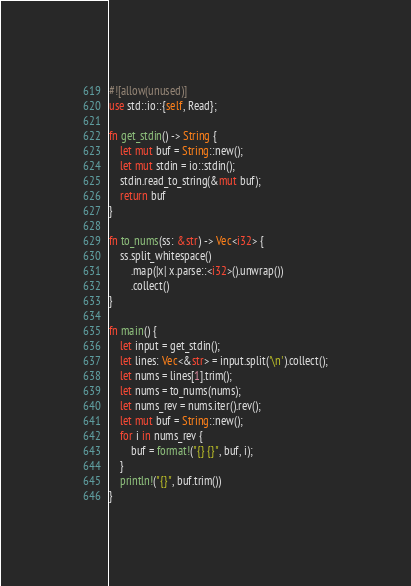Convert code to text. <code><loc_0><loc_0><loc_500><loc_500><_Rust_>#![allow(unused)]
use std::io::{self, Read};

fn get_stdin() -> String {
    let mut buf = String::new();
    let mut stdin = io::stdin();
    stdin.read_to_string(&mut buf);
    return buf
}

fn to_nums(ss: &str) -> Vec<i32> {
    ss.split_whitespace()
        .map(|x| x.parse::<i32>().unwrap())
        .collect()
}

fn main() {
    let input = get_stdin();
    let lines: Vec<&str> = input.split('\n').collect();
    let nums = lines[1].trim();
    let nums = to_nums(nums);
    let nums_rev = nums.iter().rev();
    let mut buf = String::new();
    for i in nums_rev {
        buf = format!("{} {}", buf, i);
    }
    println!("{}", buf.trim())
}

</code> 